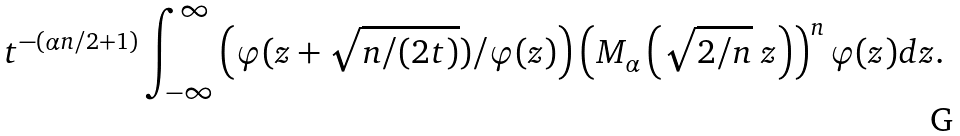<formula> <loc_0><loc_0><loc_500><loc_500>t ^ { - ( \alpha n / 2 + 1 ) } \int ^ { \infty } _ { - \infty } \left ( \varphi ( z + \sqrt { n / ( 2 t ) } ) / \varphi ( z ) \right ) \left ( M _ { \alpha } \left ( \sqrt { 2 / n } \ z \right ) \right ) ^ { n } \varphi ( z ) d z .</formula> 